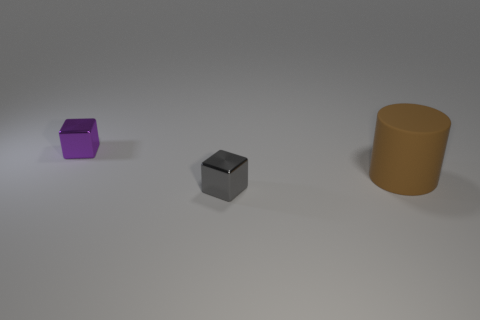Add 1 big red metal cylinders. How many objects exist? 4 Subtract all cubes. How many objects are left? 1 Subtract all large brown rubber cylinders. Subtract all brown matte objects. How many objects are left? 1 Add 2 large brown things. How many large brown things are left? 3 Add 1 tiny purple cylinders. How many tiny purple cylinders exist? 1 Subtract 0 cyan cylinders. How many objects are left? 3 